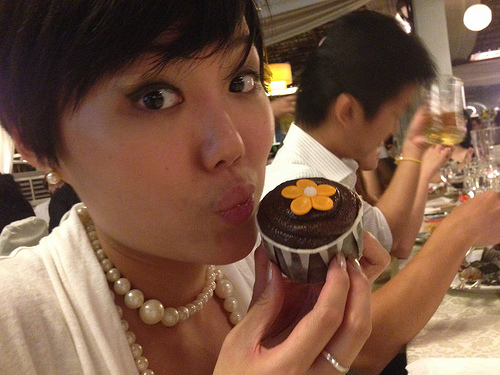Imagine this image is a scene from a movie. Write a detailed script for this scene. FADE IN:
INT. COZY RESTAURANT - EVENING
Warm lights hang overhead, casting a charming glow. Friends are gathered around a centerpiece table, enjoying a vibrant meal.

CLOSE UP on LILY (late 20s, cheerful, with a bob haircut), holding a beautifully decorated cupcake with an orange fondant flower. She puckers her lips playfully as a friend snaps a photo.

LILY
(laughing)
I can't believe you guys made this for me!

ERIC (late 20s, seated at the table, holding a beer)
We've been planning it for weeks! Happy birthday, Lily!

LILY
(eyes twinkling)
It's perfect! Thank you so much, everyone!

CUT TO WIDE SHOT of the table, everyone cheers, raising their glasses. The ambiance is filled with joyous laughter, tinkling glasses, and clinking cutlery.

At the table, diverse entrees, appetizers, and desserts are spread out, creating a fest for the senses.

JANE (late 20s, mid shot, taking a sip of her drink)
(to Lily)
And the cupcake is just the beginning. Wait 'til you see the cake!

Lily's eyes widen with excitement as she looks around the table.

LILY
You guys! Seriously, I can't handle this level of awesomeness.

The camera pans to capture the camaraderie and festivity among friends, highlighting smiles, shared stories, and heartfelt moments.
FADE OUT. 